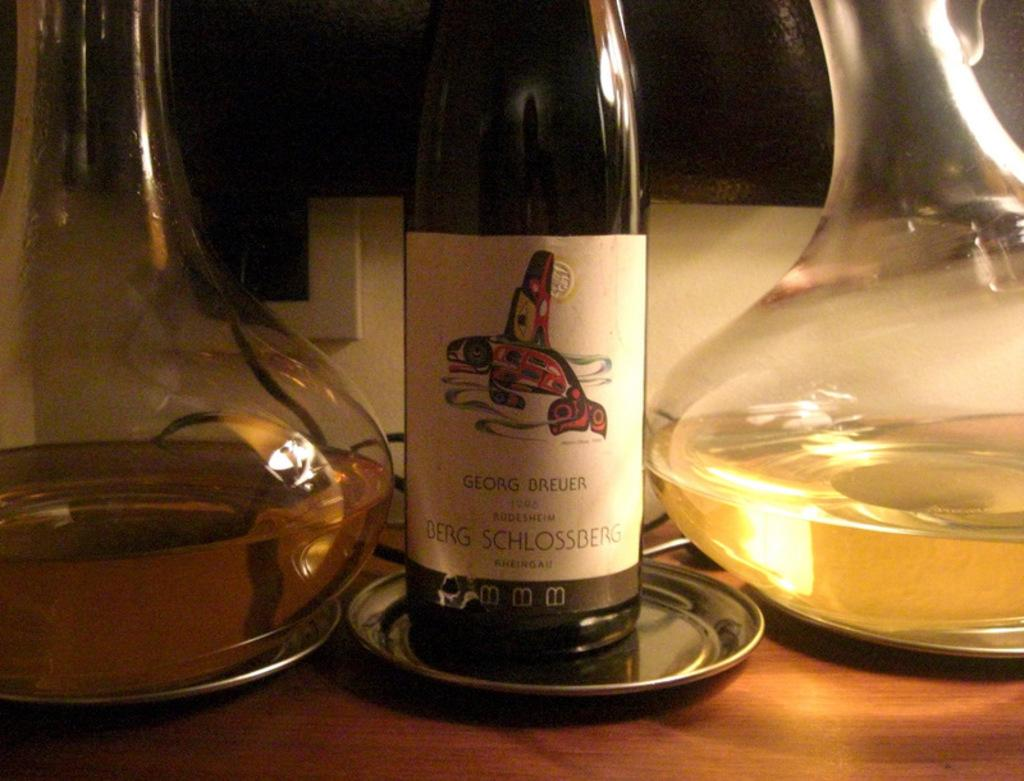<image>
Create a compact narrative representing the image presented. A wine bottle from Georg Breuer is between 2 wine decanters. 